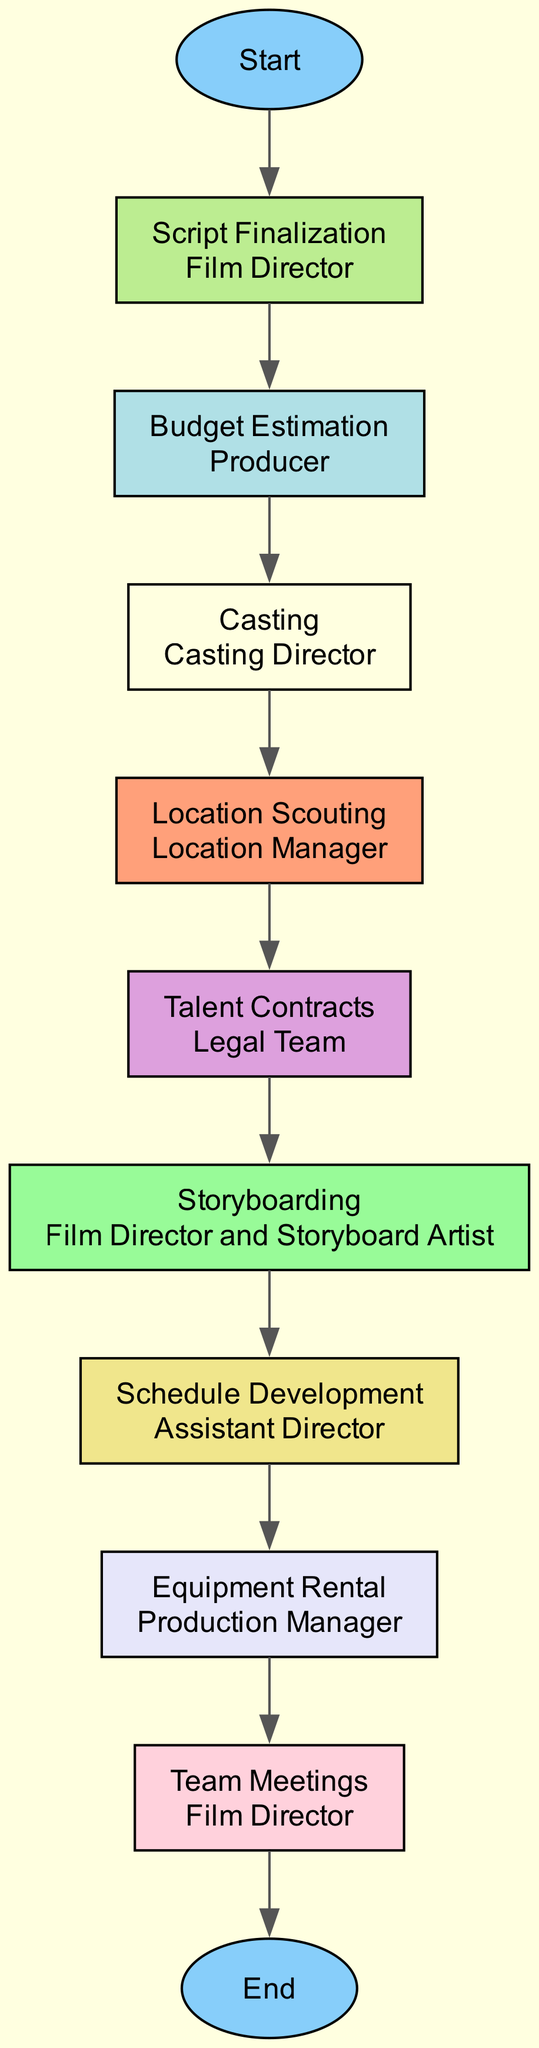What is the first task in the pre-production process? The diagram indicates that the first task is labeled "Start," which marks the beginning of the scheduling and delegation process.
Answer: Start Who is responsible for the Script Finalization task? In the diagram, the node for "Script Finalization" states that the responsible person for this task is the "Film Director."
Answer: Film Director What task follows Budget Estimation in the flowchart? Upon examining the flowchart, the task that directly follows "Budget Estimation" is "Casting," as indicated by the arrows connecting the nodes.
Answer: Casting How many tasks are there in total before reaching the End node? By counting the nodes between "Start" and "End," we find that there are nine tasks in total, which are all part of the pre-production process.
Answer: 9 Which two tasks are managed by the Film Director? Reviewing the diagram, the two tasks managed by the Film Director are "Script Finalization" and "Team Meetings," as shown in their respective nodes.
Answer: Script Finalization, Team Meetings What is the last task before the End node? The diagram shows that "Team Meetings" is the final task before reaching the "End" node, as it is the last task in the flowchart sequence.
Answer: Team Meetings Which task involves securing shooting locations? The node labeled "Location Scouting" clearly indicates that this is the task responsible for finding and securing shooting locations.
Answer: Location Scouting Who is responsible for negotiating Talent Contracts? Looking at the "Talent Contracts" node, it is indicated that the "Legal Team" is responsible for this task based on the diagram's labeling.
Answer: Legal Team What type of representation is created in the Storyboarding task? The description under the "Storyboarding" task states that it involves creating visual representations of scenes, as reflected in the task's labeling.
Answer: Visual representations 